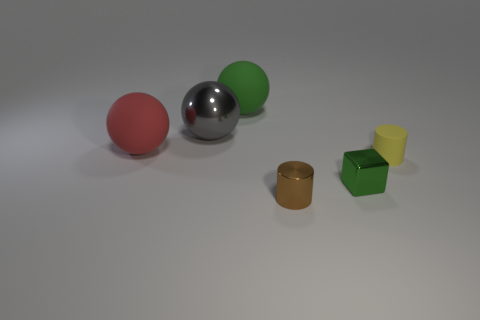Are there any other small shiny blocks that have the same color as the tiny block?
Offer a very short reply. No. There is a cylinder that is the same size as the yellow matte object; what is its color?
Your answer should be compact. Brown. Does the green thing that is in front of the red thing have the same material as the red object?
Your answer should be compact. No. There is a shiny object behind the big matte ball that is in front of the large green matte sphere; is there a large metal object behind it?
Offer a terse response. No. Does the large thing that is right of the gray sphere have the same shape as the small green thing?
Provide a succinct answer. No. What shape is the big rubber object that is in front of the big matte thing that is behind the big red rubber ball?
Give a very brief answer. Sphere. There is a yellow thing that is to the right of the matte sphere in front of the green thing behind the gray shiny sphere; what is its size?
Provide a succinct answer. Small. There is another thing that is the same shape as the brown object; what is its color?
Offer a terse response. Yellow. Do the cube and the red matte thing have the same size?
Make the answer very short. No. There is a green thing in front of the red thing; what is its material?
Give a very brief answer. Metal. 